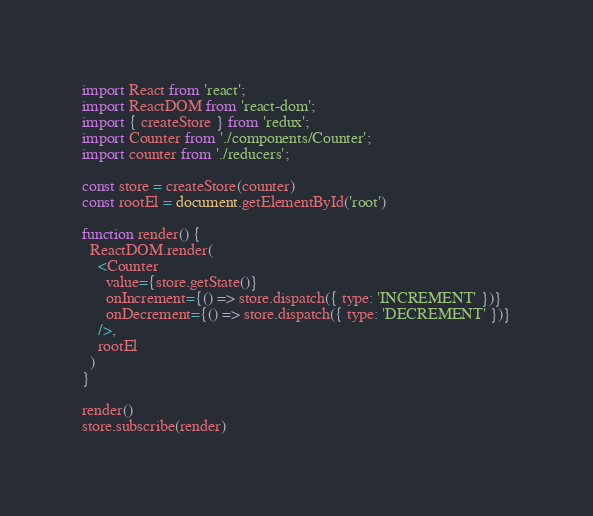Convert code to text. <code><loc_0><loc_0><loc_500><loc_500><_JavaScript_>import React from 'react';
import ReactDOM from 'react-dom';
import { createStore } from 'redux';
import Counter from './components/Counter';
import counter from './reducers';

const store = createStore(counter)
const rootEl = document.getElementById('root')

function render() {
  ReactDOM.render(
    <Counter
      value={store.getState()}
      onIncrement={() => store.dispatch({ type: 'INCREMENT' })}
      onDecrement={() => store.dispatch({ type: 'DECREMENT' })}
    />,
    rootEl
  )
}

render()
store.subscribe(render)
</code> 